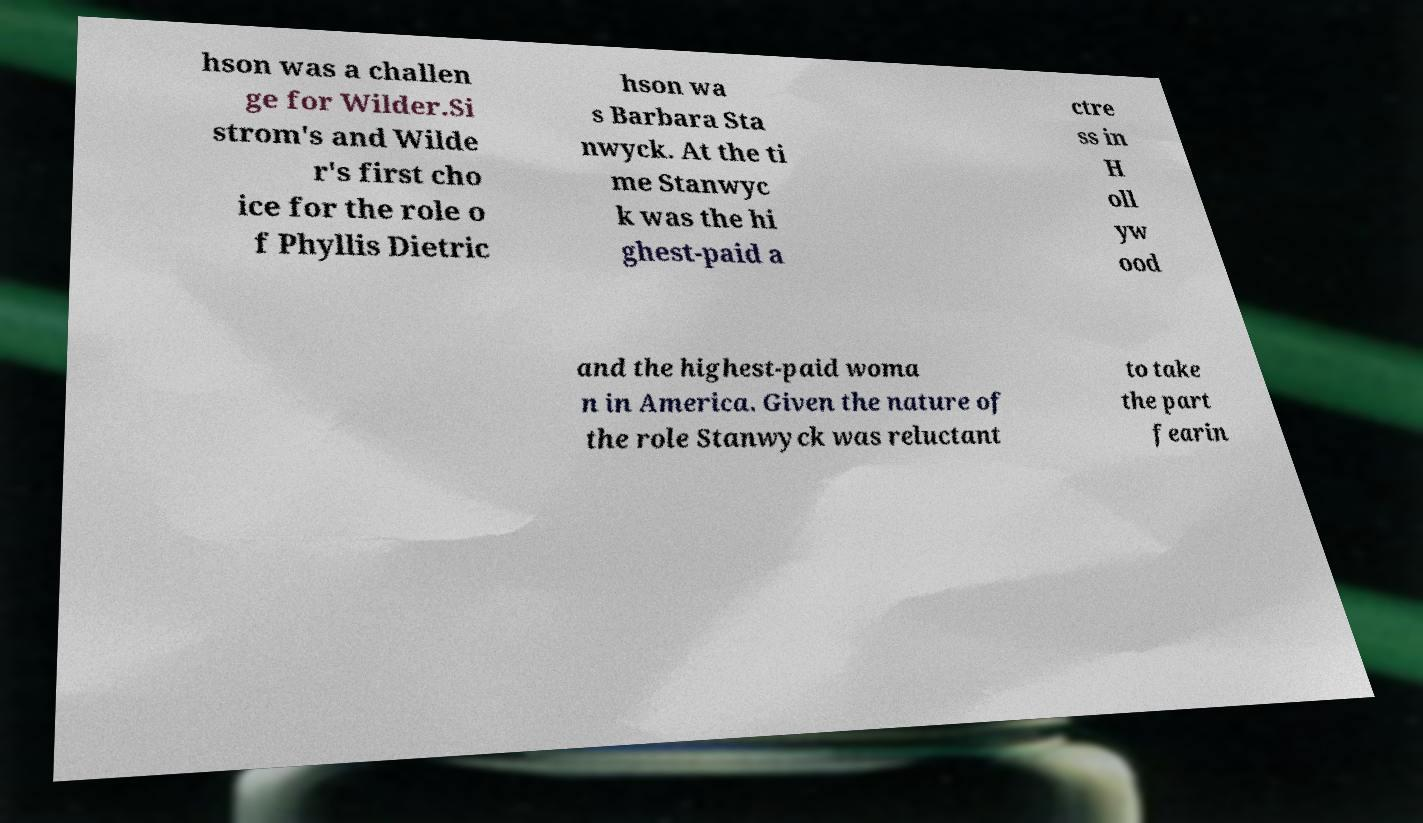Could you extract and type out the text from this image? hson was a challen ge for Wilder.Si strom's and Wilde r's first cho ice for the role o f Phyllis Dietric hson wa s Barbara Sta nwyck. At the ti me Stanwyc k was the hi ghest-paid a ctre ss in H oll yw ood and the highest-paid woma n in America. Given the nature of the role Stanwyck was reluctant to take the part fearin 